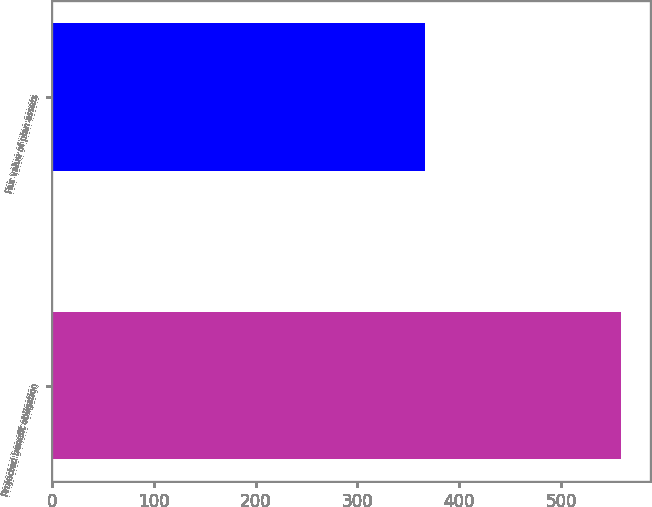Convert chart. <chart><loc_0><loc_0><loc_500><loc_500><bar_chart><fcel>Projected benefit obligation<fcel>Fair value of plan assets<nl><fcel>559<fcel>366<nl></chart> 